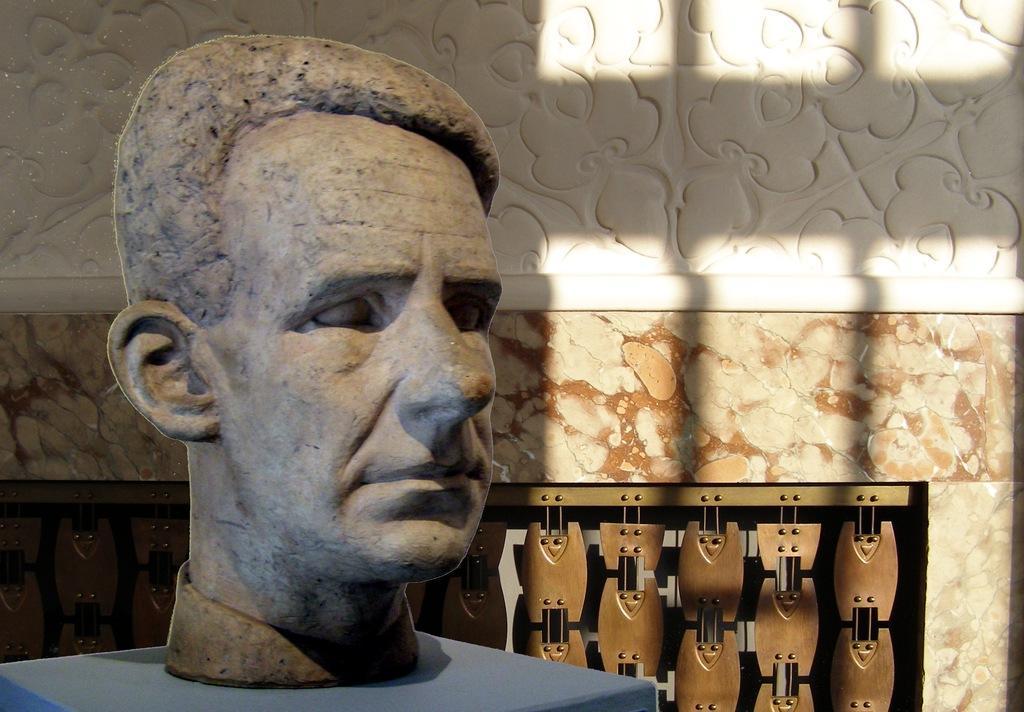How would you summarize this image in a sentence or two? In this image I can see the statue of the person on the blue color surface. The wall is in white and cream color and I can see the brown color object to the wall. 